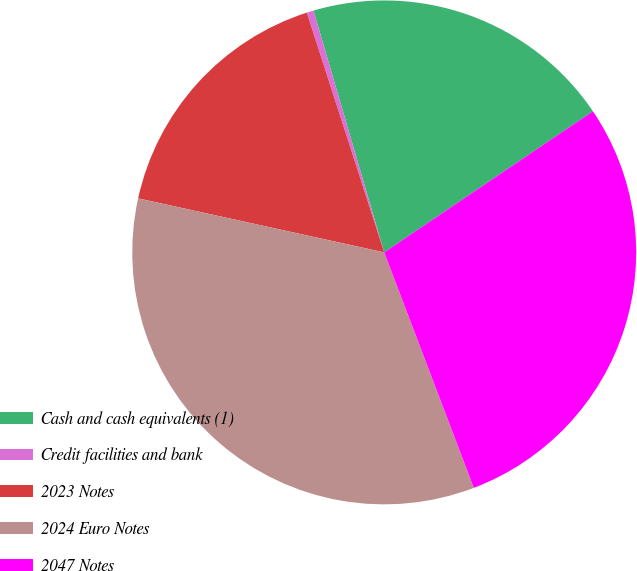<chart> <loc_0><loc_0><loc_500><loc_500><pie_chart><fcel>Cash and cash equivalents (1)<fcel>Credit facilities and bank<fcel>2023 Notes<fcel>2024 Euro Notes<fcel>2047 Notes<nl><fcel>20.07%<fcel>0.44%<fcel>16.59%<fcel>34.23%<fcel>28.68%<nl></chart> 